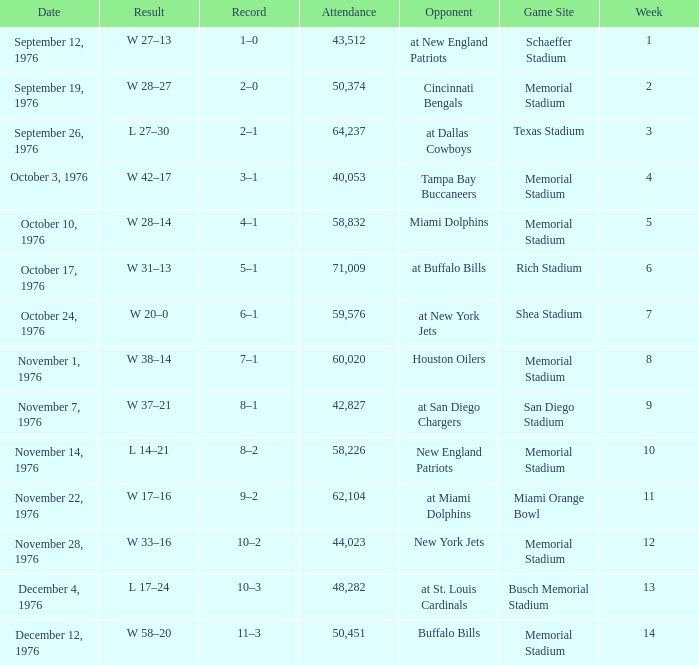How many people attended the game at the miami orange bowl? 62104.0. 